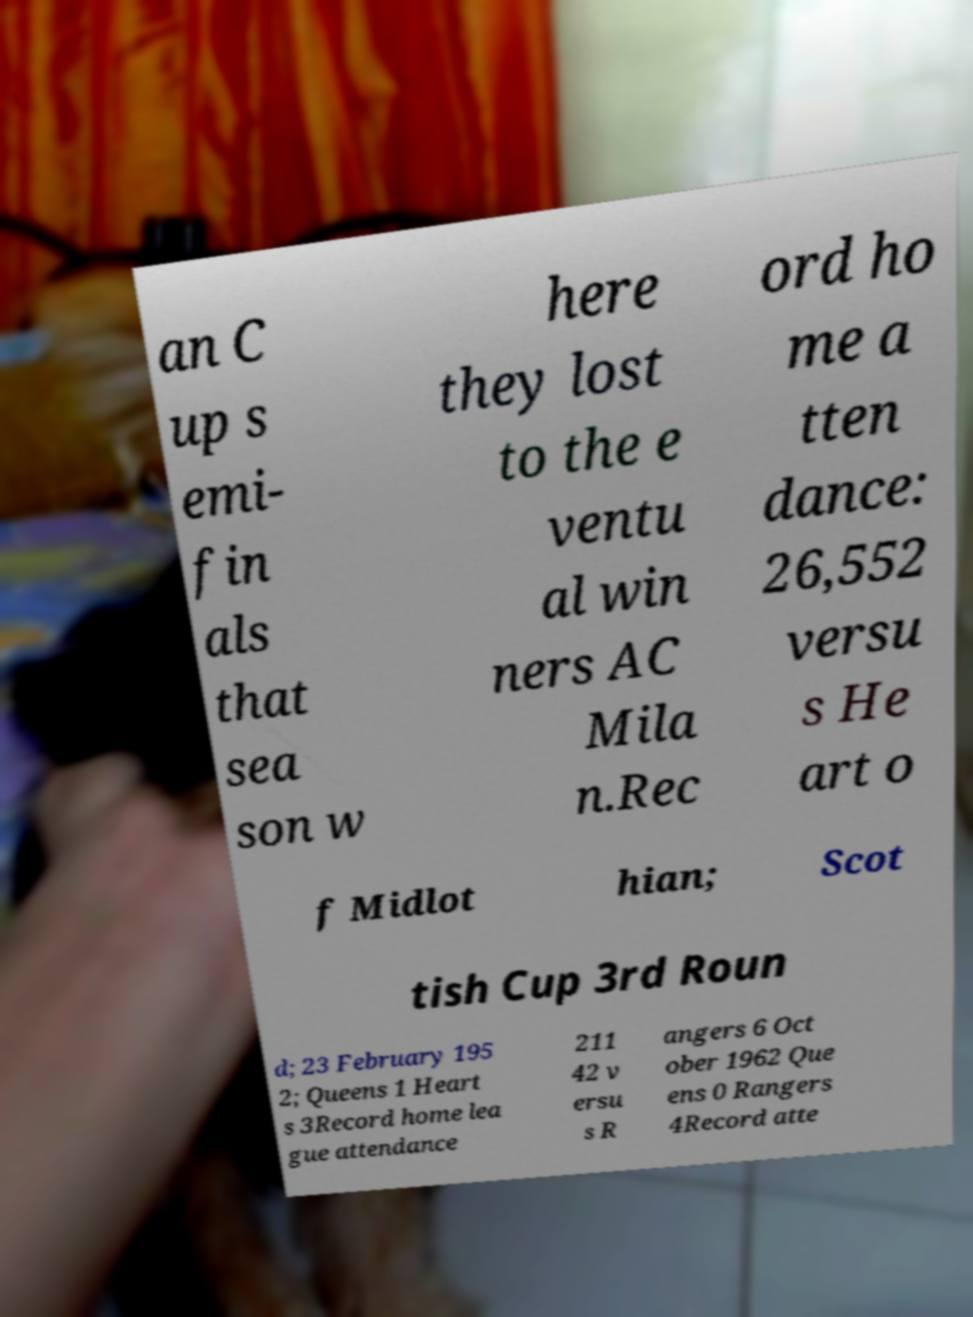Could you assist in decoding the text presented in this image and type it out clearly? an C up s emi- fin als that sea son w here they lost to the e ventu al win ners AC Mila n.Rec ord ho me a tten dance: 26,552 versu s He art o f Midlot hian; Scot tish Cup 3rd Roun d; 23 February 195 2; Queens 1 Heart s 3Record home lea gue attendance 211 42 v ersu s R angers 6 Oct ober 1962 Que ens 0 Rangers 4Record atte 